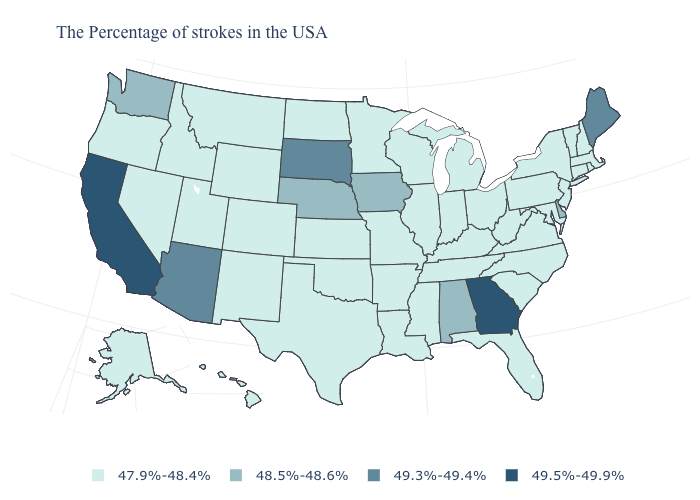Name the states that have a value in the range 48.5%-48.6%?
Short answer required. Delaware, Alabama, Iowa, Nebraska, Washington. Which states have the lowest value in the USA?
Give a very brief answer. Massachusetts, Rhode Island, New Hampshire, Vermont, Connecticut, New York, New Jersey, Maryland, Pennsylvania, Virginia, North Carolina, South Carolina, West Virginia, Ohio, Florida, Michigan, Kentucky, Indiana, Tennessee, Wisconsin, Illinois, Mississippi, Louisiana, Missouri, Arkansas, Minnesota, Kansas, Oklahoma, Texas, North Dakota, Wyoming, Colorado, New Mexico, Utah, Montana, Idaho, Nevada, Oregon, Alaska, Hawaii. Is the legend a continuous bar?
Concise answer only. No. Does Washington have the lowest value in the West?
Keep it brief. No. Does the map have missing data?
Be succinct. No. Name the states that have a value in the range 48.5%-48.6%?
Concise answer only. Delaware, Alabama, Iowa, Nebraska, Washington. What is the value of Washington?
Be succinct. 48.5%-48.6%. Among the states that border Tennessee , does Alabama have the lowest value?
Short answer required. No. Does the map have missing data?
Quick response, please. No. Is the legend a continuous bar?
Be succinct. No. Name the states that have a value in the range 49.5%-49.9%?
Quick response, please. Georgia, California. Is the legend a continuous bar?
Keep it brief. No. Name the states that have a value in the range 49.3%-49.4%?
Short answer required. Maine, South Dakota, Arizona. Does California have the highest value in the USA?
Concise answer only. Yes. What is the value of Nevada?
Write a very short answer. 47.9%-48.4%. 